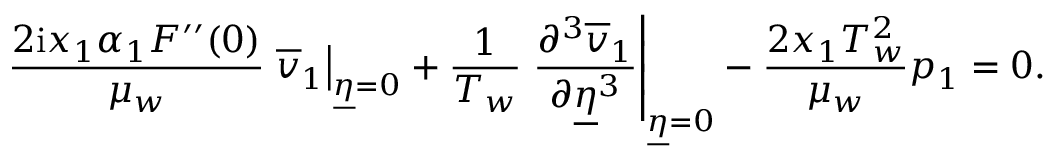<formula> <loc_0><loc_0><loc_500><loc_500>\frac { 2 i x _ { 1 } \alpha _ { 1 } F ^ { \prime \prime } ( 0 ) } { \mu _ { w } } \overline { v } _ { 1 } \right | _ { \underline { \eta } = 0 } + \frac { 1 } { T _ { w } } \frac { \partial ^ { 3 } \overline { v } _ { 1 } } { \partial \underline { \eta } ^ { 3 } } \right | _ { \underline { \eta } = 0 } - \frac { 2 x _ { 1 } T _ { w } ^ { 2 } } { \mu _ { w } } p _ { 1 } = 0 .</formula> 